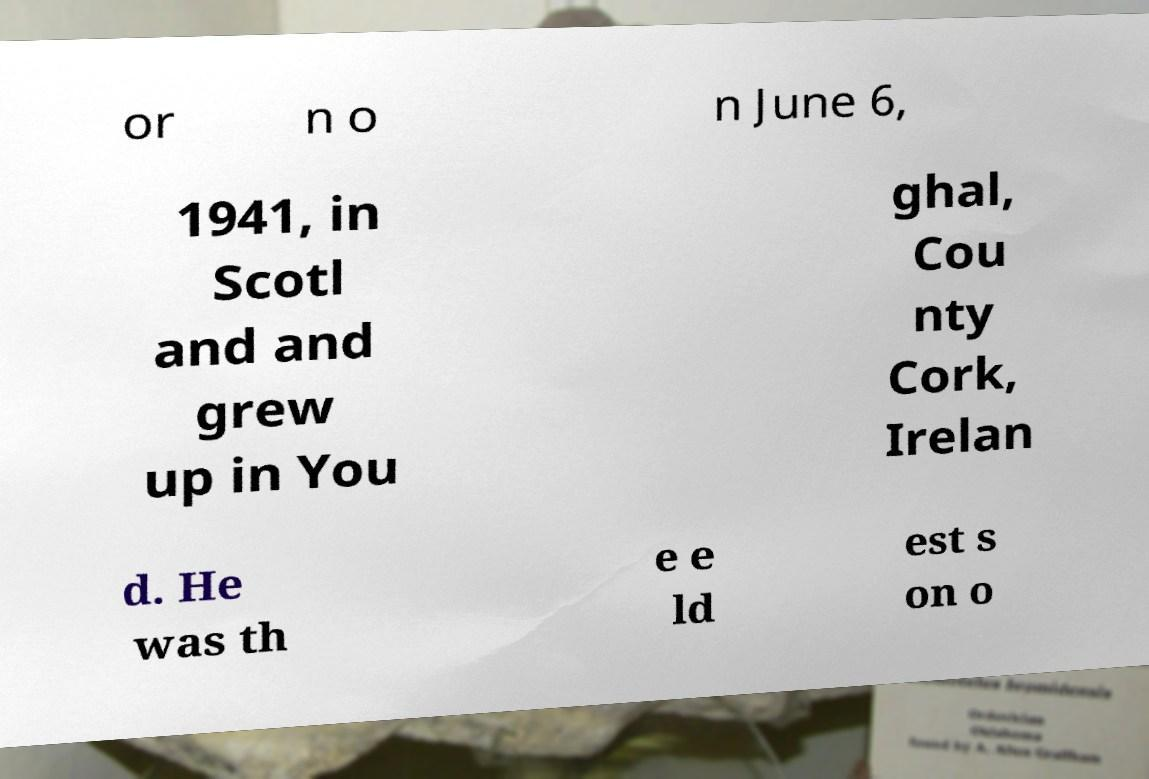Could you extract and type out the text from this image? or n o n June 6, 1941, in Scotl and and grew up in You ghal, Cou nty Cork, Irelan d. He was th e e ld est s on o 